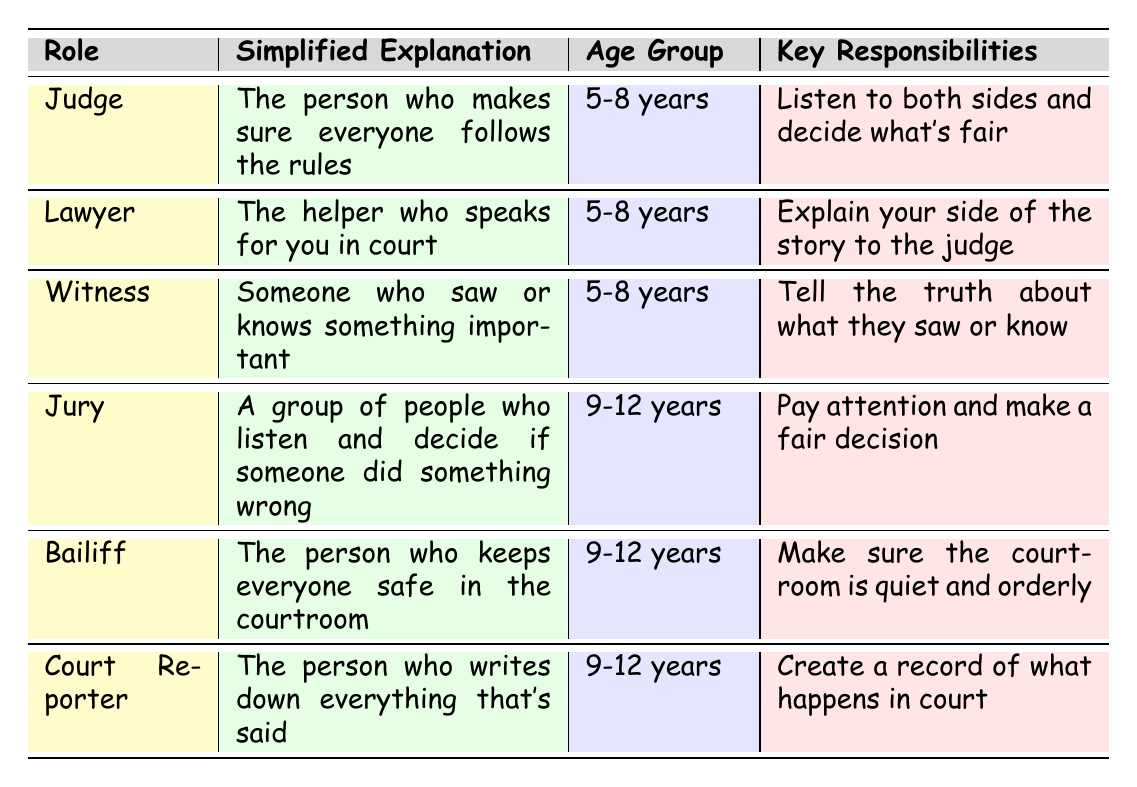What is the simplified explanation of the role of a Judge? The table shows that the Judge's simplified explanation is "The person who makes sure everyone follows the rules." This information is directly retrievable from the specified row in the table.
Answer: The person who makes sure everyone follows the rules Which roles are intended for the 5-8 years age group? By looking at the table, the roles for the 5-8 years age group are Judge, Lawyer, and Witness. This can be found in the Age Group column.
Answer: Judge, Lawyer, Witness What are the key responsibilities of the Jury? The Jury's key responsibility is stated in the table as "Pay attention and make a fair decision." This information can be directly retrieved from the relevant row.
Answer: Pay attention and make a fair decision Is the Court Reporter responsible for creating a record of what happens in court? Based on the table, the key responsibility of the Court Reporter is "Create a record of what happens in court," which confirms that the statement is true.
Answer: Yes How many roles are designated for the age group 9-12 years? The table lists three roles that are for the 9-12 years age group: Jury, Bailiff, and Court Reporter. Therefore, by counting these roles, we find the answer.
Answer: Three Which role requires telling the truth about something someone saw or knew? Looking at the table, the role that requires telling the truth about something someone saw or knew is the Witness, as indicated in the relevant column.
Answer: Witness What is the difference between the age groups of Witness and Bailiff? The Witness is for the 5-8 years age group, while the Bailiff is for the 9-12 years age group. The difference in their age groups is 4 years.
Answer: 4 years If a child is 10 years old, which courtroom roles would they relate to? A 10-year-old would relate to the roles for the 9-12 years age group. Those roles are Jury, Bailiff, and Court Reporter, as retrieved from the appropriate age group in the table.
Answer: Jury, Bailiff, Court Reporter Which role is responsible for ensuring the courtroom is quiet and orderly? The Bailiff is responsible for keeping the courtroom quiet and orderly, as stated in their key responsibilities section in the table.
Answer: Bailiff What are the responsibilities of a Lawyer compared to a Witness? The Lawyer's responsibility is to "Explain your side of the story to the judge," while the Witness's responsibility is to "Tell the truth about what they saw or know." Comparing these, the tasks are related but distinct, centered around narrative versus testimony.
Answer: Lawyer: Explain your side; Witness: Tell the truth 